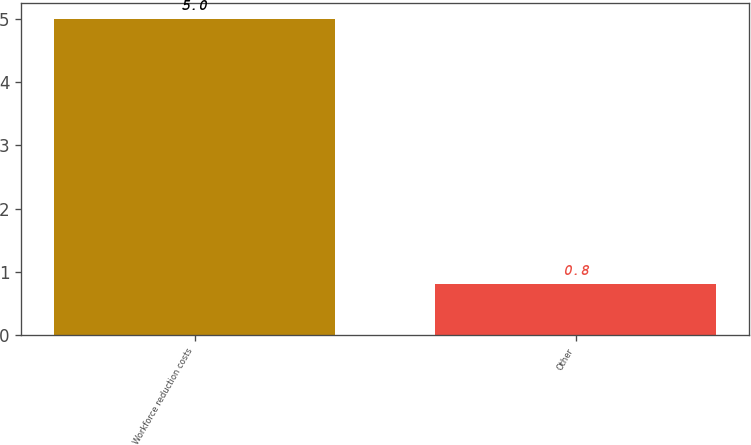Convert chart to OTSL. <chart><loc_0><loc_0><loc_500><loc_500><bar_chart><fcel>Workforce reduction costs<fcel>Other<nl><fcel>5<fcel>0.8<nl></chart> 